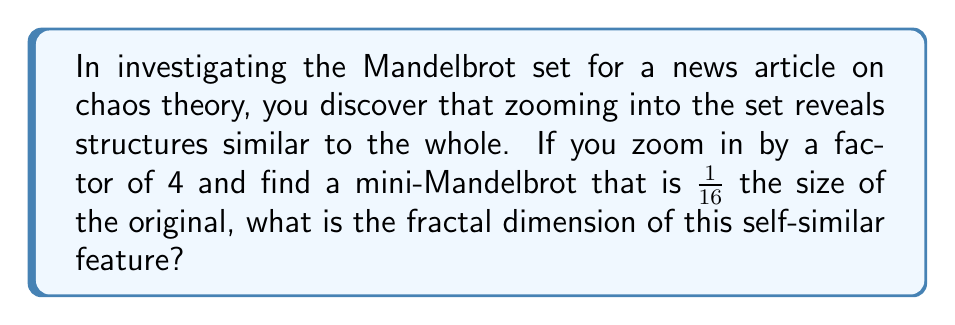What is the answer to this math problem? To solve this problem, we'll use the concept of fractal dimension in self-similar structures:

1. The general formula for fractal dimension (D) is:
   $$D = \frac{\log N}{\log S}$$
   Where N is the number of self-similar pieces and S is the scaling factor.

2. In this case, we're zooming in by a factor of 4, so S = 4.

3. The mini-Mandelbrot is $\frac{1}{16}$ the size of the original. This means that if we scaled up the mini-Mandelbrot by 4 in each dimension, it would match the original.

4. In two dimensions, scaling by 4 in each direction results in $4 * 4 = 16$ total scaling, which matches our observation. Therefore, N = 16.

5. Plugging these values into our formula:
   $$D = \frac{\log 16}{\log 4}$$

6. Simplify:
   $$D = \frac{\log 2^4}{\log 2^2} = \frac{4 \log 2}{2 \log 2} = \frac{4}{2} = 2$$

Therefore, the fractal dimension of this self-similar feature is 2.
Answer: 2 